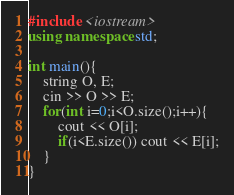Convert code to text. <code><loc_0><loc_0><loc_500><loc_500><_C++_>#include <iostream>
using namespace std;

int main(){
	string O, E;
	cin >> O >> E;
	for(int i=0;i<O.size();i++){
		cout << O[i];
		if(i<E.size()) cout << E[i];
	}
}</code> 